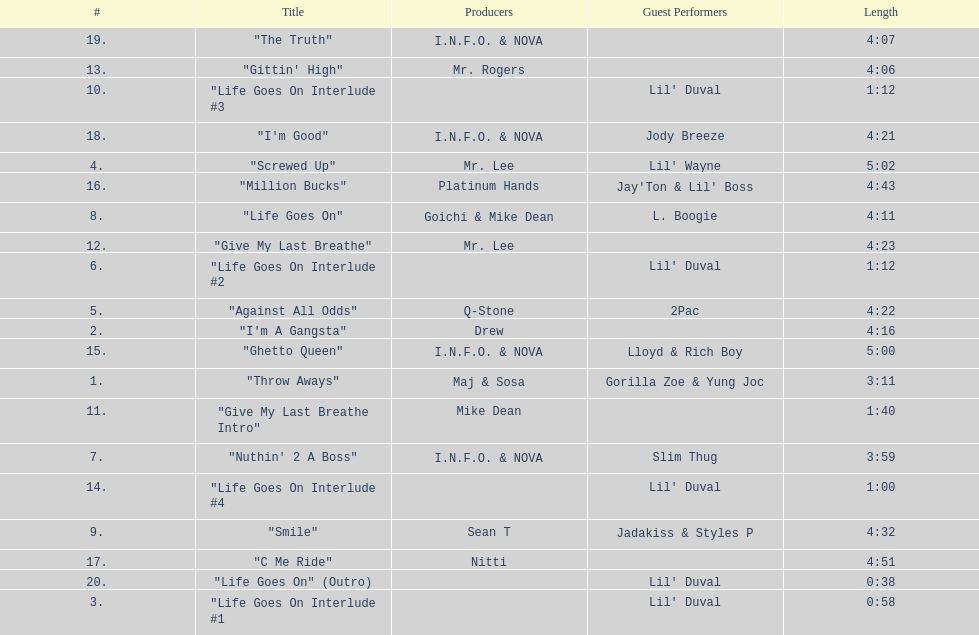What is the longest track on the album? "Screwed Up". 